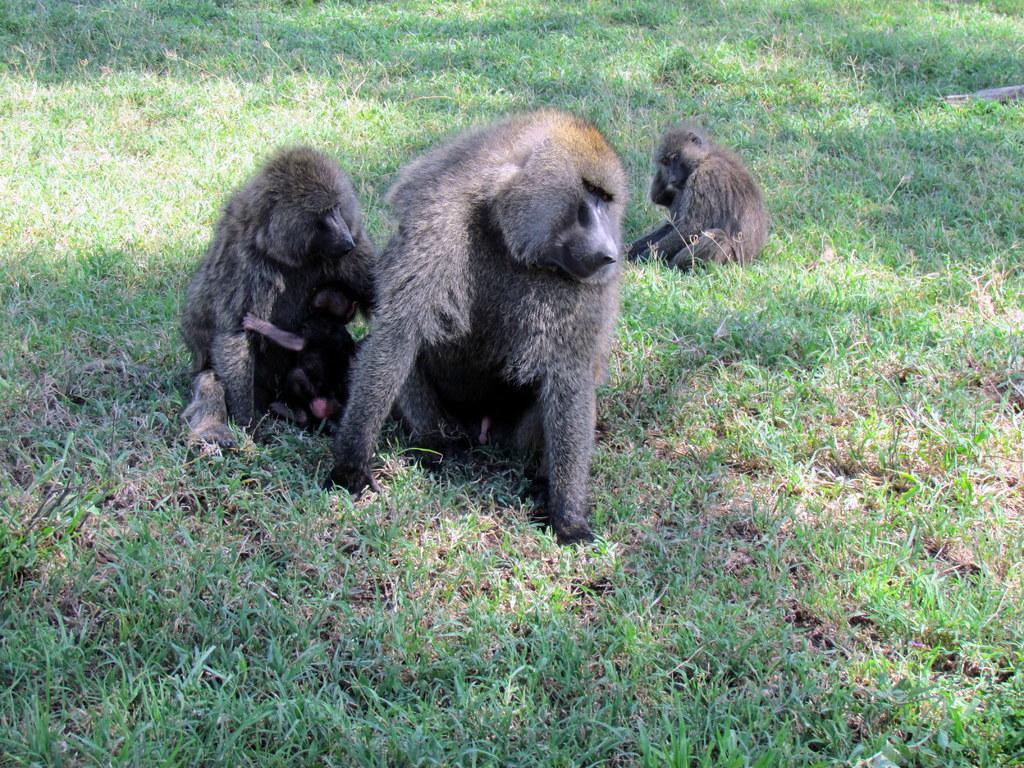How would you summarize this image in a sentence or two? In this picture we can see animals are sitting on the grass. 